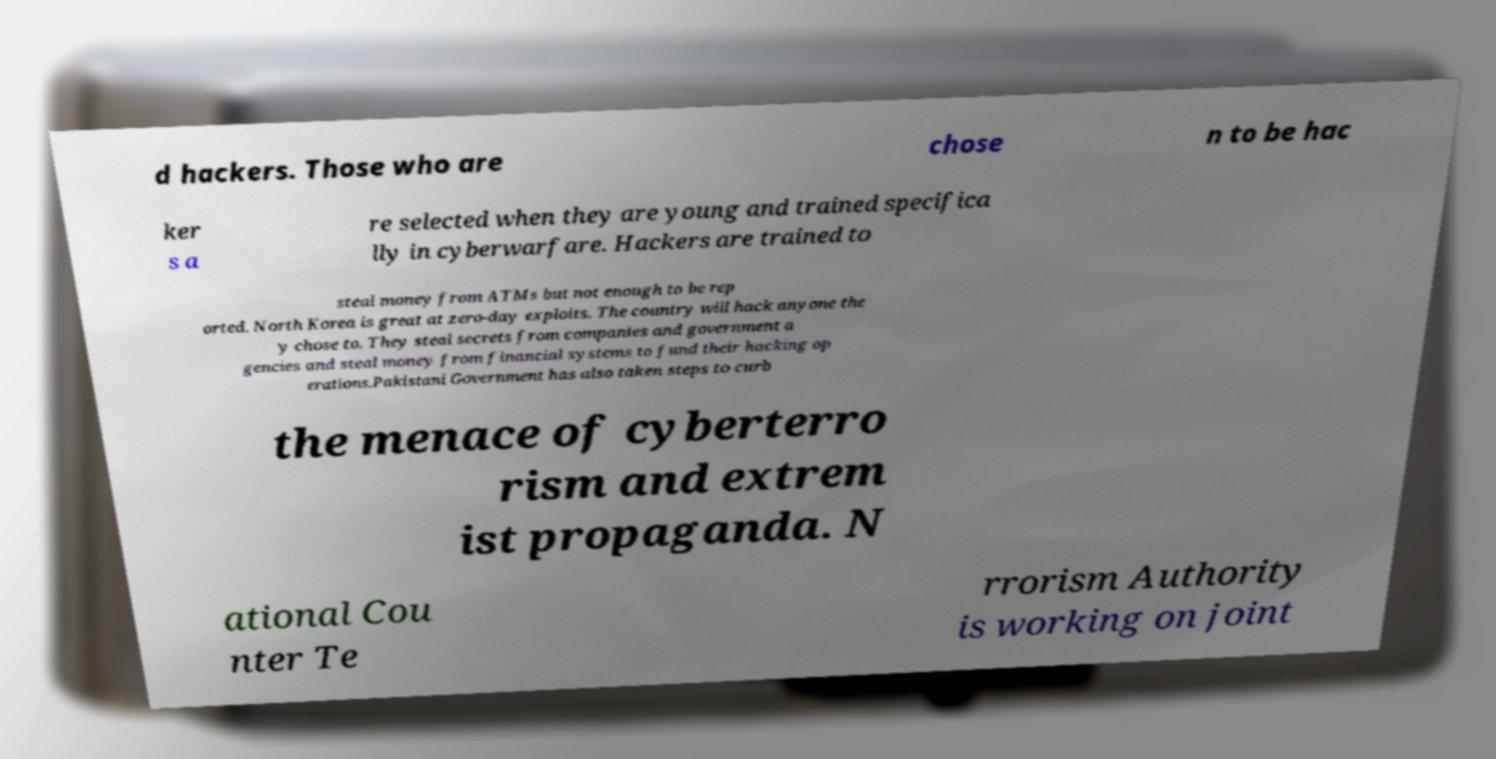Can you accurately transcribe the text from the provided image for me? d hackers. Those who are chose n to be hac ker s a re selected when they are young and trained specifica lly in cyberwarfare. Hackers are trained to steal money from ATMs but not enough to be rep orted. North Korea is great at zero-day exploits. The country will hack anyone the y chose to. They steal secrets from companies and government a gencies and steal money from financial systems to fund their hacking op erations.Pakistani Government has also taken steps to curb the menace of cyberterro rism and extrem ist propaganda. N ational Cou nter Te rrorism Authority is working on joint 